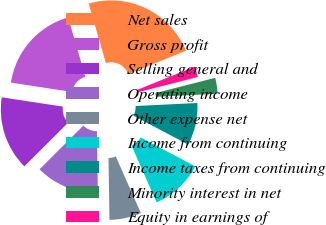Convert chart. <chart><loc_0><loc_0><loc_500><loc_500><pie_chart><fcel>Net sales<fcel>Gross profit<fcel>Selling general and<fcel>Operating income<fcel>Other expense net<fcel>Income from continuing<fcel>Income taxes from continuing<fcel>Minority interest in net<fcel>Equity in earnings of<nl><fcel>23.4%<fcel>18.09%<fcel>14.89%<fcel>12.77%<fcel>6.38%<fcel>10.64%<fcel>8.51%<fcel>3.19%<fcel>2.13%<nl></chart> 